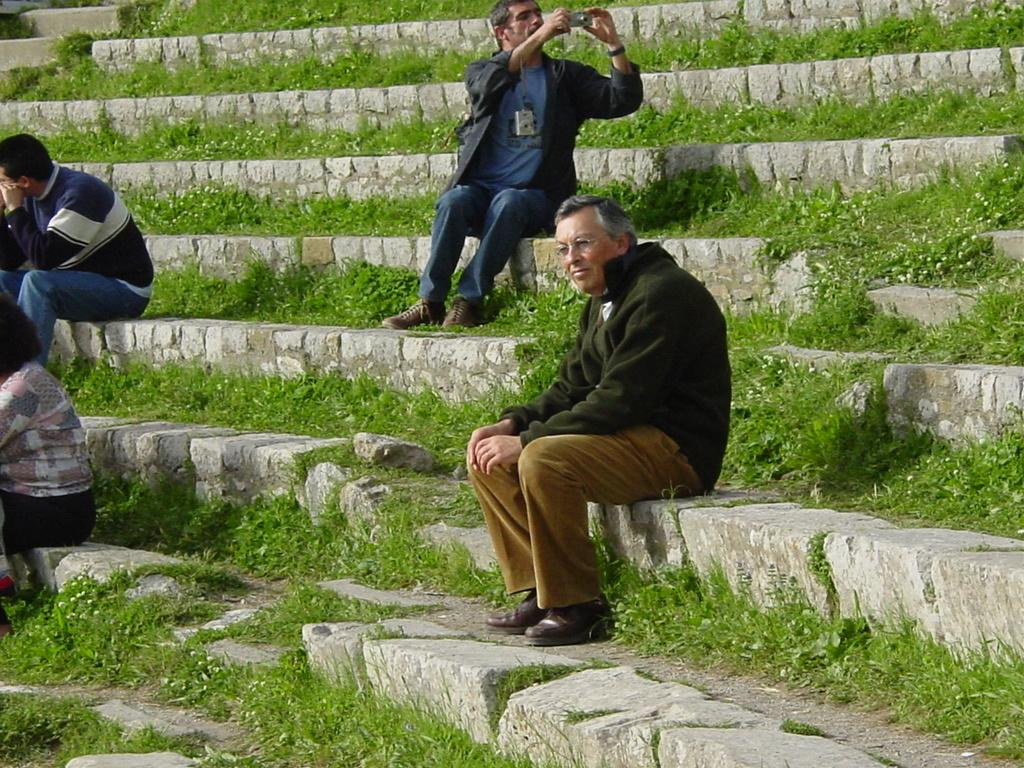How many people are sitting on the steps in the image? There are four people sitting on the steps in the image. What is the man holding in his hands? The man is holding a camera with his hands. What can be seen in the background of the image? There are plants visible in the background. Can you see any worms crawling on the steps in the image? No, there are no worms visible in the image. 